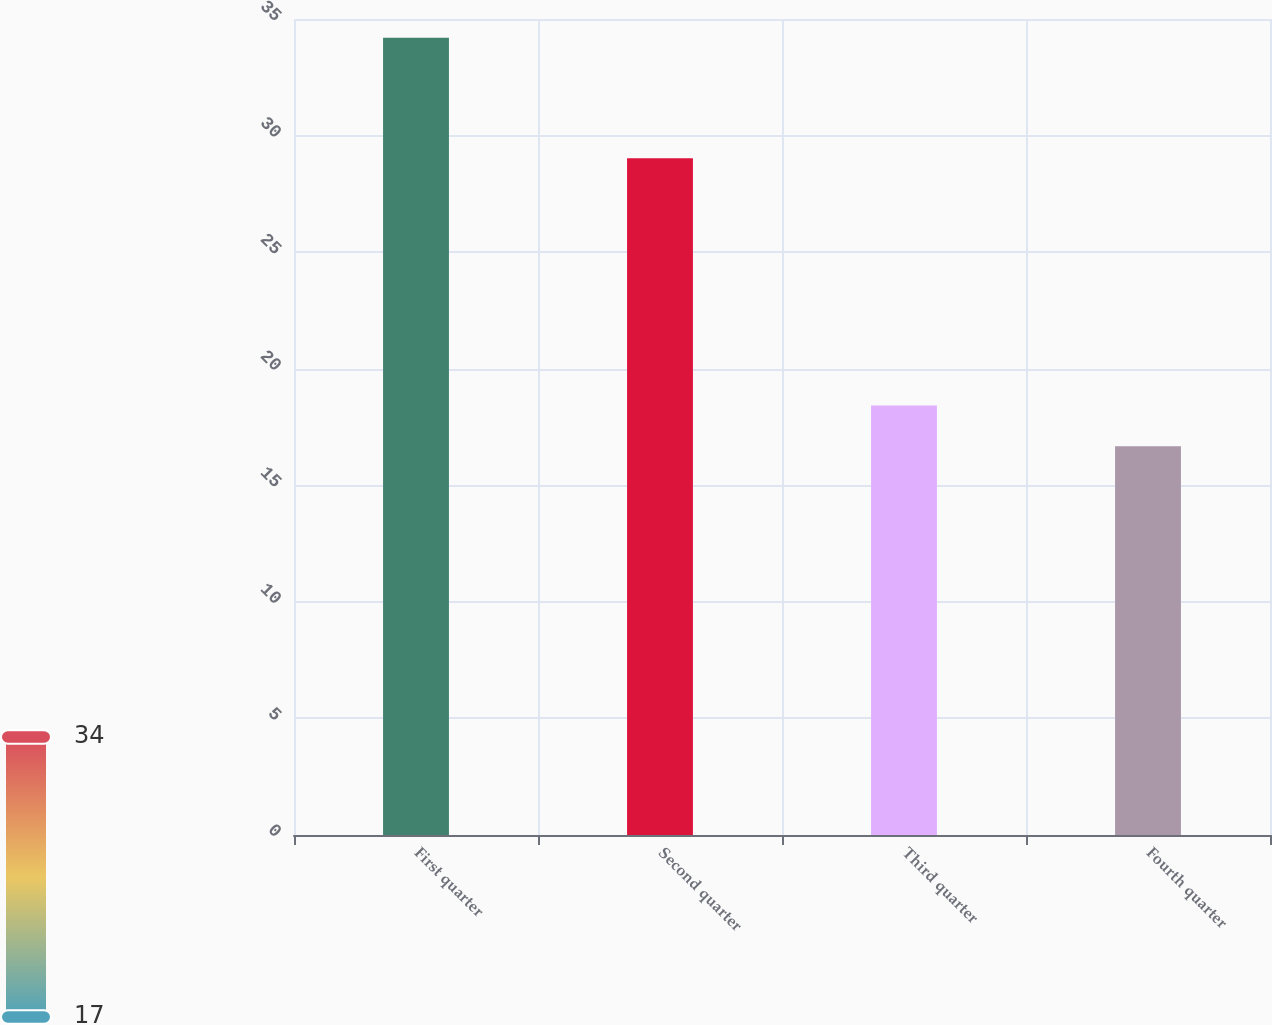<chart> <loc_0><loc_0><loc_500><loc_500><bar_chart><fcel>First quarter<fcel>Second quarter<fcel>Third quarter<fcel>Fourth quarter<nl><fcel>34.2<fcel>29.03<fcel>18.42<fcel>16.67<nl></chart> 